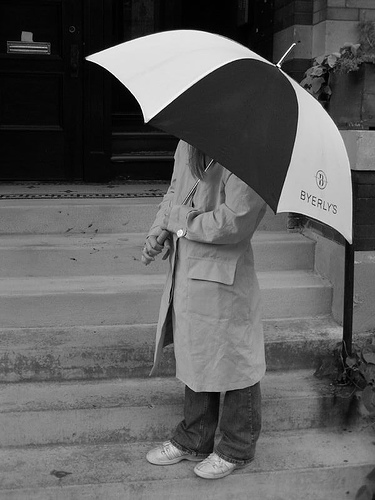<image>What part of this picture is humorous? It is ambiguous what part of the picture is humorous. It could be a kid dressed like an adult, a short man, or something else. What part of this picture is humorous? I don't know what part of this picture is humorous. There are different possibilities, such as the kid dressed like an adult, the short man, or the oversize objects. 